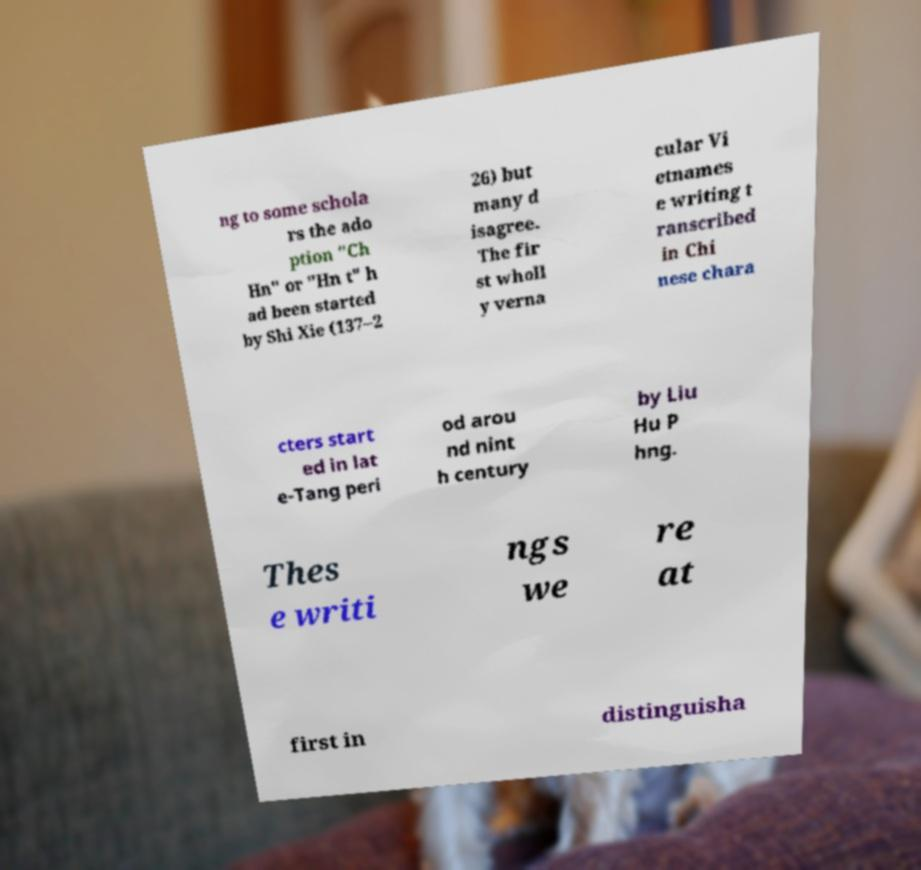Could you assist in decoding the text presented in this image and type it out clearly? ng to some schola rs the ado ption "Ch Hn" or "Hn t" h ad been started by Shi Xie (137–2 26) but many d isagree. The fir st wholl y verna cular Vi etnames e writing t ranscribed in Chi nese chara cters start ed in lat e-Tang peri od arou nd nint h century by Liu Hu P hng. Thes e writi ngs we re at first in distinguisha 